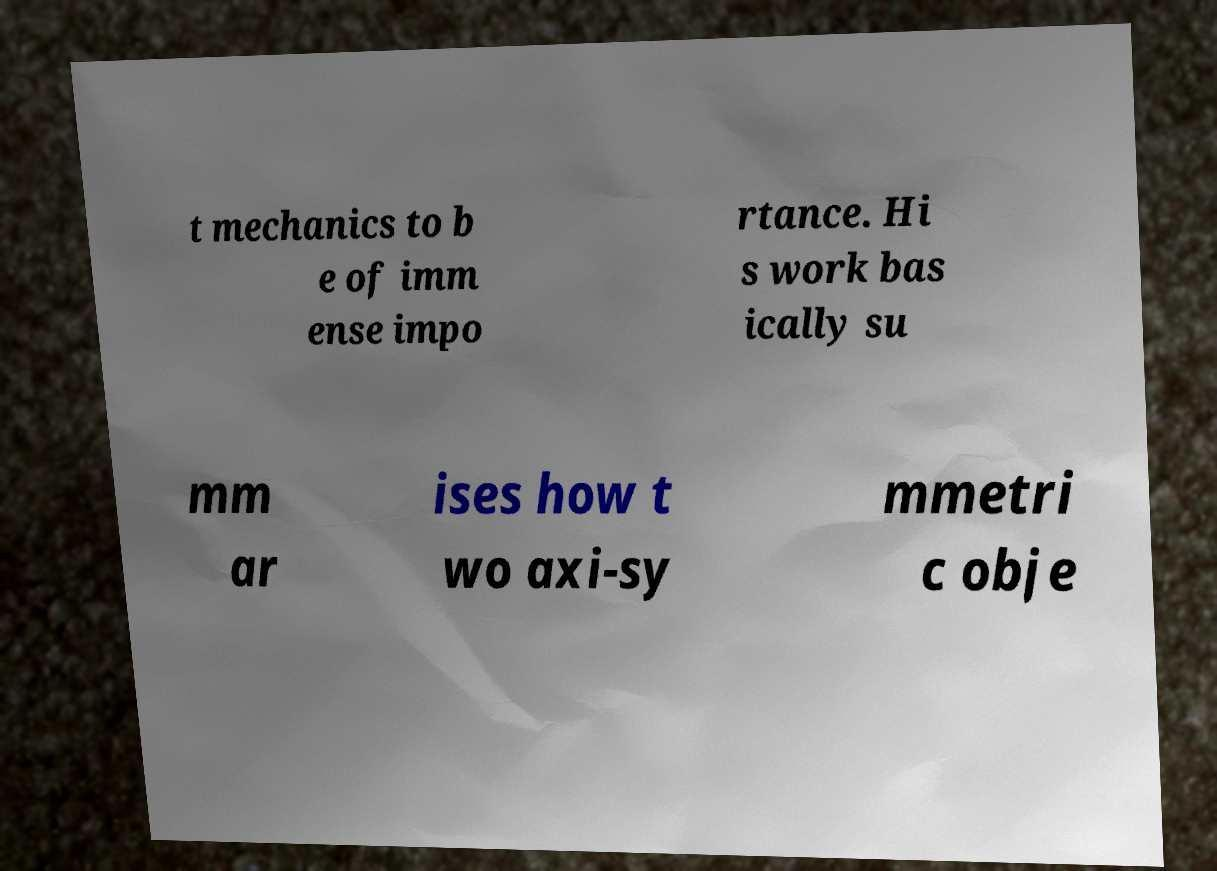There's text embedded in this image that I need extracted. Can you transcribe it verbatim? t mechanics to b e of imm ense impo rtance. Hi s work bas ically su mm ar ises how t wo axi-sy mmetri c obje 